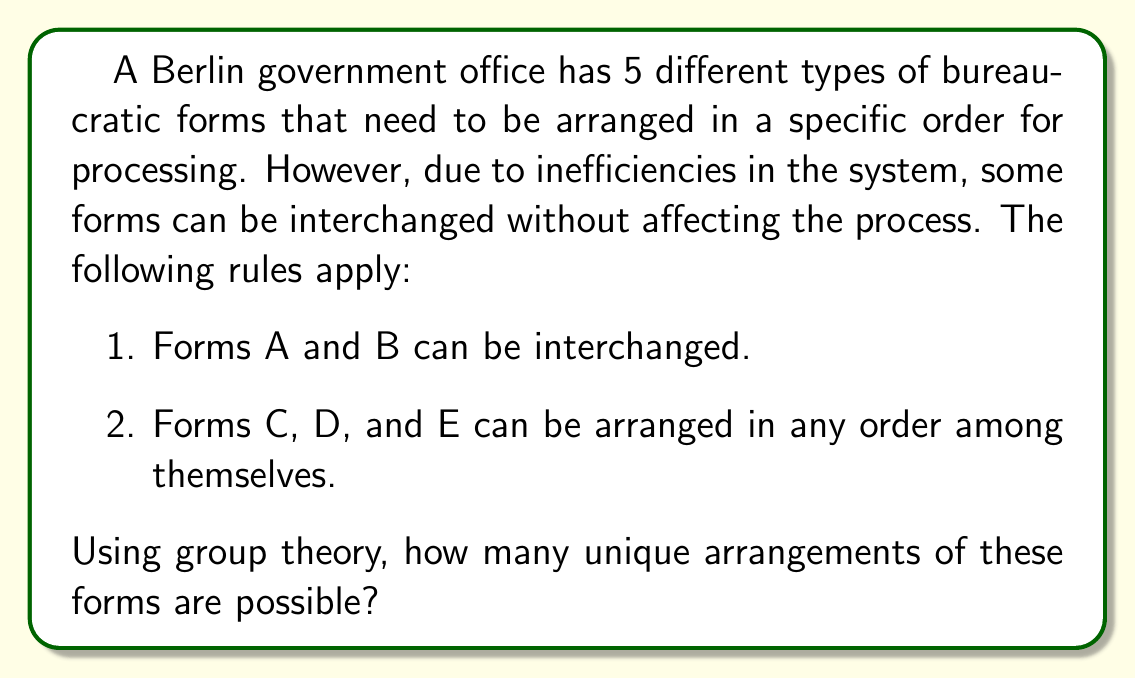Solve this math problem. To solve this problem, we'll use the concept of permutation groups and the orbit-stabilizer theorem.

1) First, let's consider the total number of permutations without restrictions:
   There are 5! = 120 ways to arrange 5 distinct objects.

2) Now, let's analyze the given rules:
   - Forms A and B can be interchanged: This forms a subgroup of order 2.
   - Forms C, D, and E can be arranged in any order: This forms a subgroup of order 3! = 6.

3) These subgroups act independently on different positions, so we can consider their direct product:
   $G = S_2 \times S_3$

4) The order of this group is:
   $|G| = |S_2| \times |S_3| = 2 \times 6 = 12$

5) By the orbit-stabilizer theorem, the number of unique arrangements (orbits) is equal to the total number of permutations divided by the order of our group:

   $$\text{Number of unique arrangements} = \frac{|S_5|}{|G|} = \frac{5!}{12} = \frac{120}{12} = 10$$

Therefore, there are 10 unique arrangements of the forms.
Answer: 10 unique arrangements 